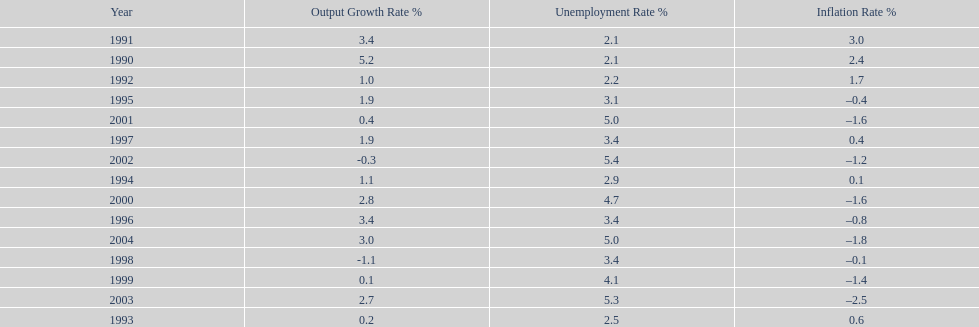In what years, between 1990 and 2004, did japan's unemployment rate reach 5% or higher? 4. 